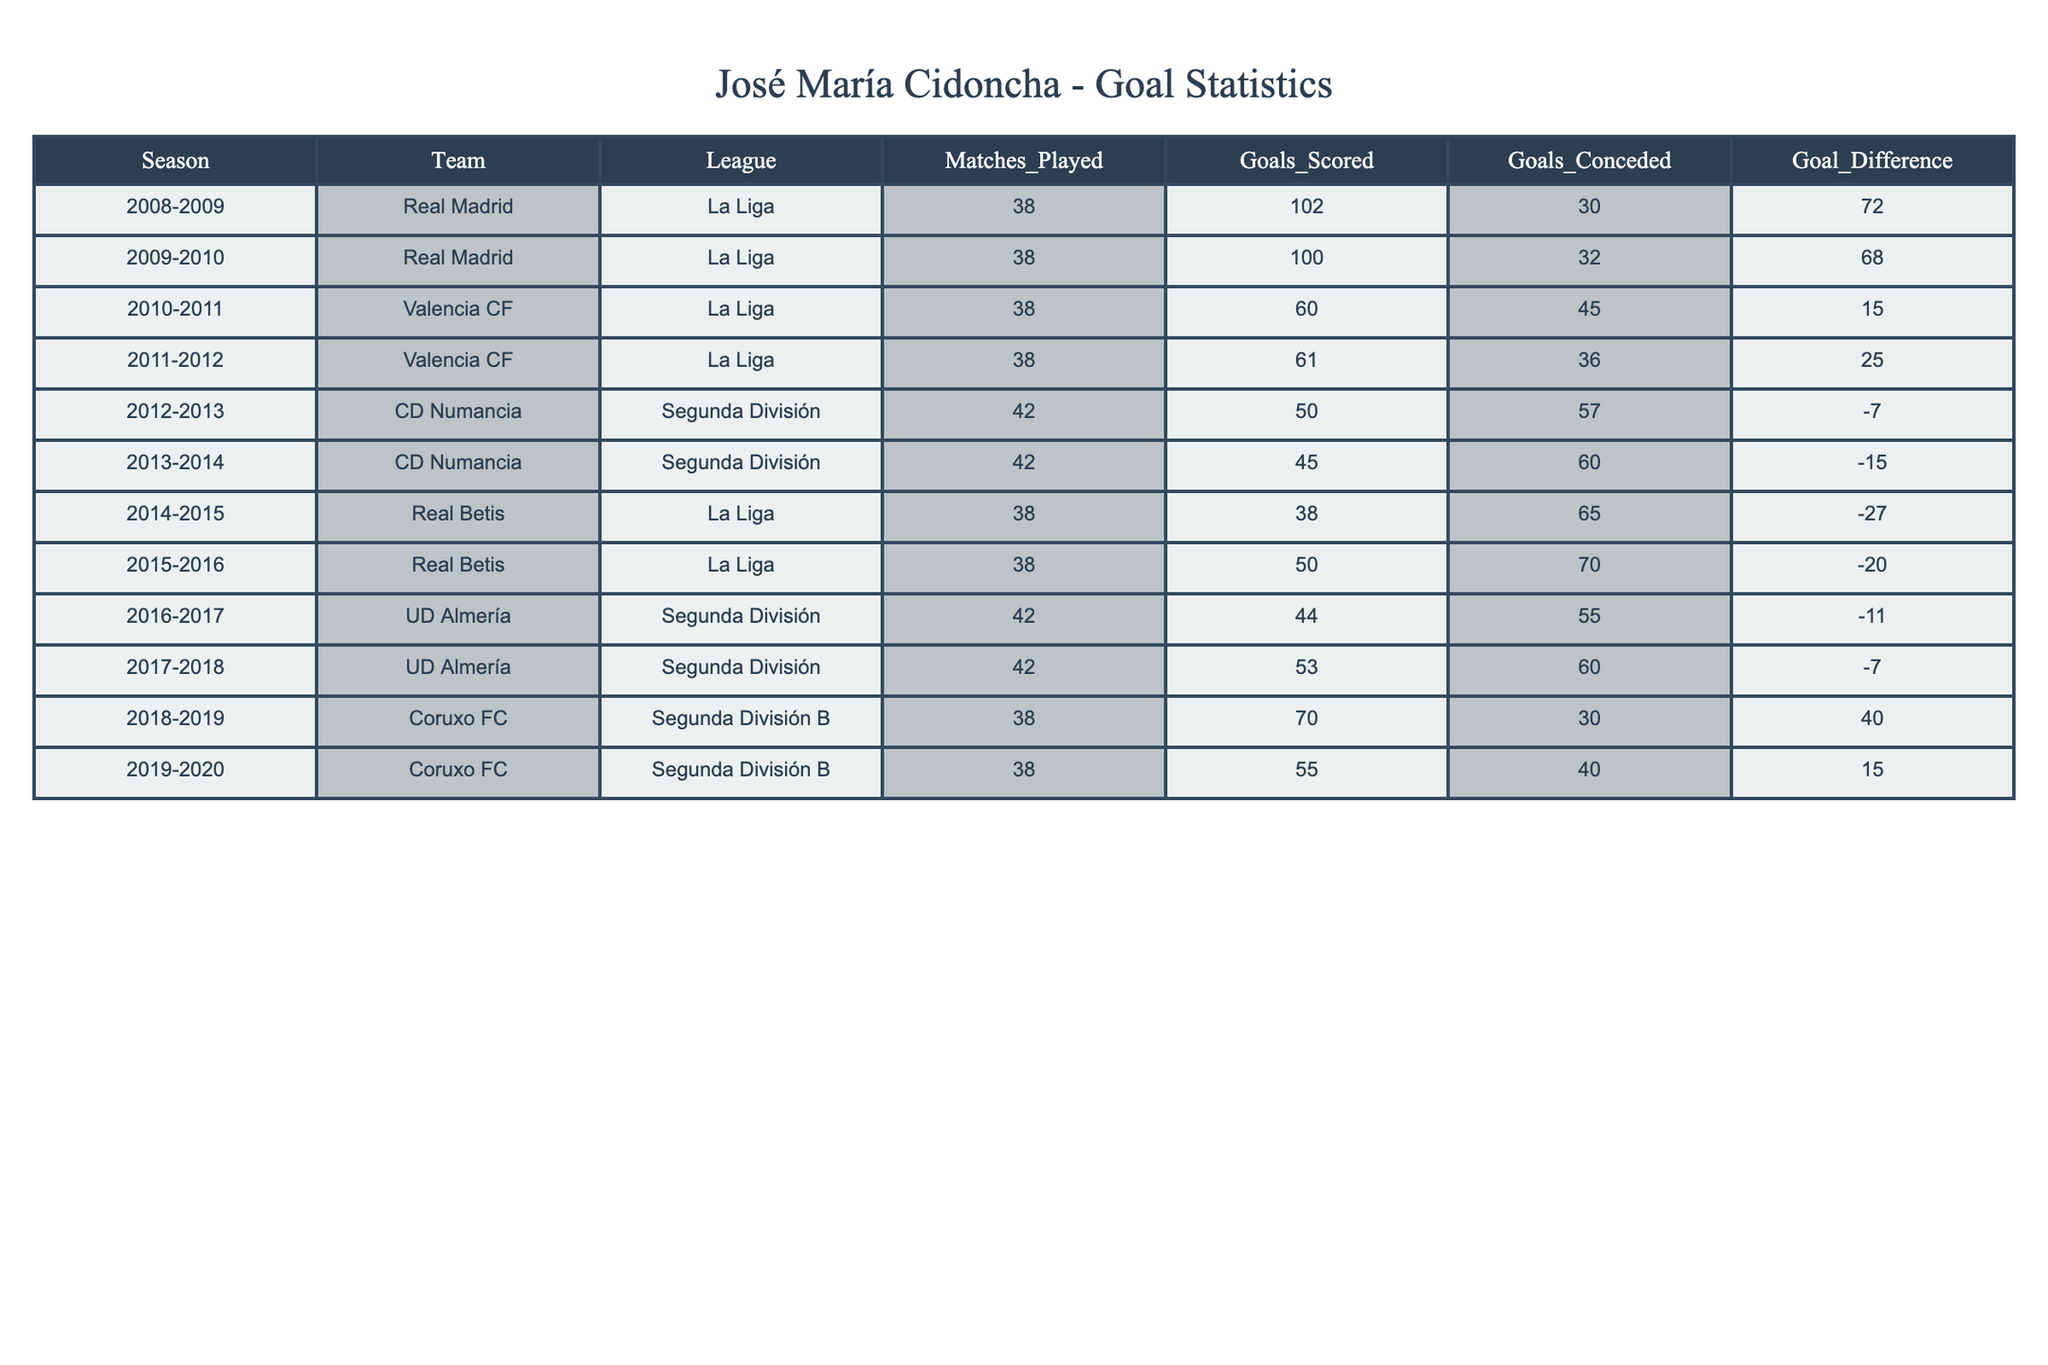What was the total number of goals scored by Real Madrid during José María Cidoncha's tenure? Real Madrid played two seasons in the table: 2008-2009 and 2009-2010, scoring 102 and 100 goals respectively. Adding these together gives a total of 102 + 100 = 202 goals scored by Real Madrid.
Answer: 202 Which team had the highest goal difference in the league matches mentioned? The team with the highest goal difference is Coruxo FC, which in the 2018-2019 season had a goal difference of 40 (70 scored - 30 conceded). This is higher than any other team's goal difference in the table.
Answer: Coruxo FC Did José María Cidoncha's teams ever experience a season with negative goal difference in La Liga? Yes, Real Betis and Valencia CF both experienced seasons with a negative goal difference in La Liga. Real Betis had a goal difference of -27 in 2014-2015, and Valencia CF had a goal difference of -7 in the 2010-2011 season.
Answer: Yes What is the average number of goals scored by José María Cidoncha's teams in the Segunda División? José María Cidoncha played in four seasons in the Segunda División with CD Numancia and UD Almería, scoring a total of 50 + 45 + 44 + 53 = 192 goals over 42 matches each season (total matches = 42 + 42 + 42 + 42 = 168). The average goals scored per match is 192 / 168 = 1.14.
Answer: 1.14 Which team conceded the most goals during the seasons listed? The team that conceded the most goals is Real Betis, which conceded 70 goals in the 2015-2016 season. This is the highest number when comparing all teams in the table.
Answer: Real Betis In which season did José María Cidoncha's team score the least number of goals? The season during which Cidoncha's team scored the least number of goals was 2014-2015 while playing for Real Betis, with only 38 goals scored.
Answer: 2014-2015 How many seasons did José María Cidoncha play for teams that finished with a positive goal difference? To find the seasons with positive goal difference, we check each entry: Real Madrid in 2008-2009 (72), Real Madrid in 2009-2010 (68), Valencia CF in 2011-2012 (25), UD Almería in 2017-2018 (−7), and Coruxo FC in 2018-2019 (40). This gives us 4 seasons with a positive goal difference.
Answer: 4 Was José María Cidoncha part of any team that finished a season with a total of over 100 goals scored? Yes, Real Madrid scored over 100 goals in both the 2008-2009 (102 goals) and the 2009-2010 (100 goals) seasons. Therefore, he was part of a team that finished with more than 100 goals scored in those two seasons.
Answer: Yes 